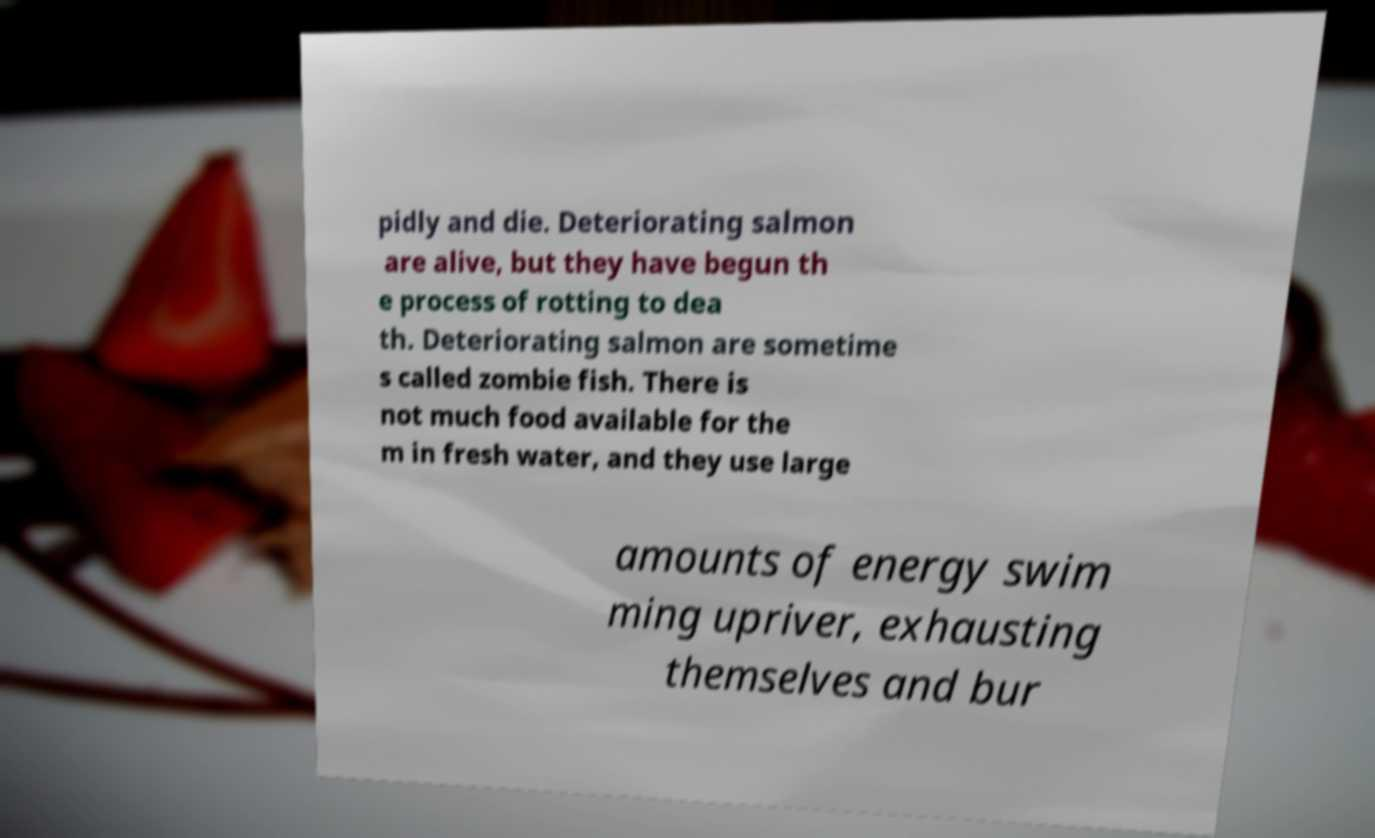What messages or text are displayed in this image? I need them in a readable, typed format. pidly and die. Deteriorating salmon are alive, but they have begun th e process of rotting to dea th. Deteriorating salmon are sometime s called zombie fish. There is not much food available for the m in fresh water, and they use large amounts of energy swim ming upriver, exhausting themselves and bur 